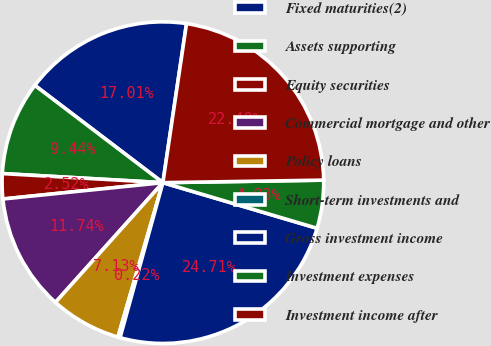<chart> <loc_0><loc_0><loc_500><loc_500><pie_chart><fcel>Fixed maturities(2)<fcel>Assets supporting<fcel>Equity securities<fcel>Commercial mortgage and other<fcel>Policy loans<fcel>Short-term investments and<fcel>Gross investment income<fcel>Investment expenses<fcel>Investment income after<nl><fcel>17.01%<fcel>9.44%<fcel>2.52%<fcel>11.74%<fcel>7.13%<fcel>0.22%<fcel>24.71%<fcel>4.83%<fcel>22.4%<nl></chart> 